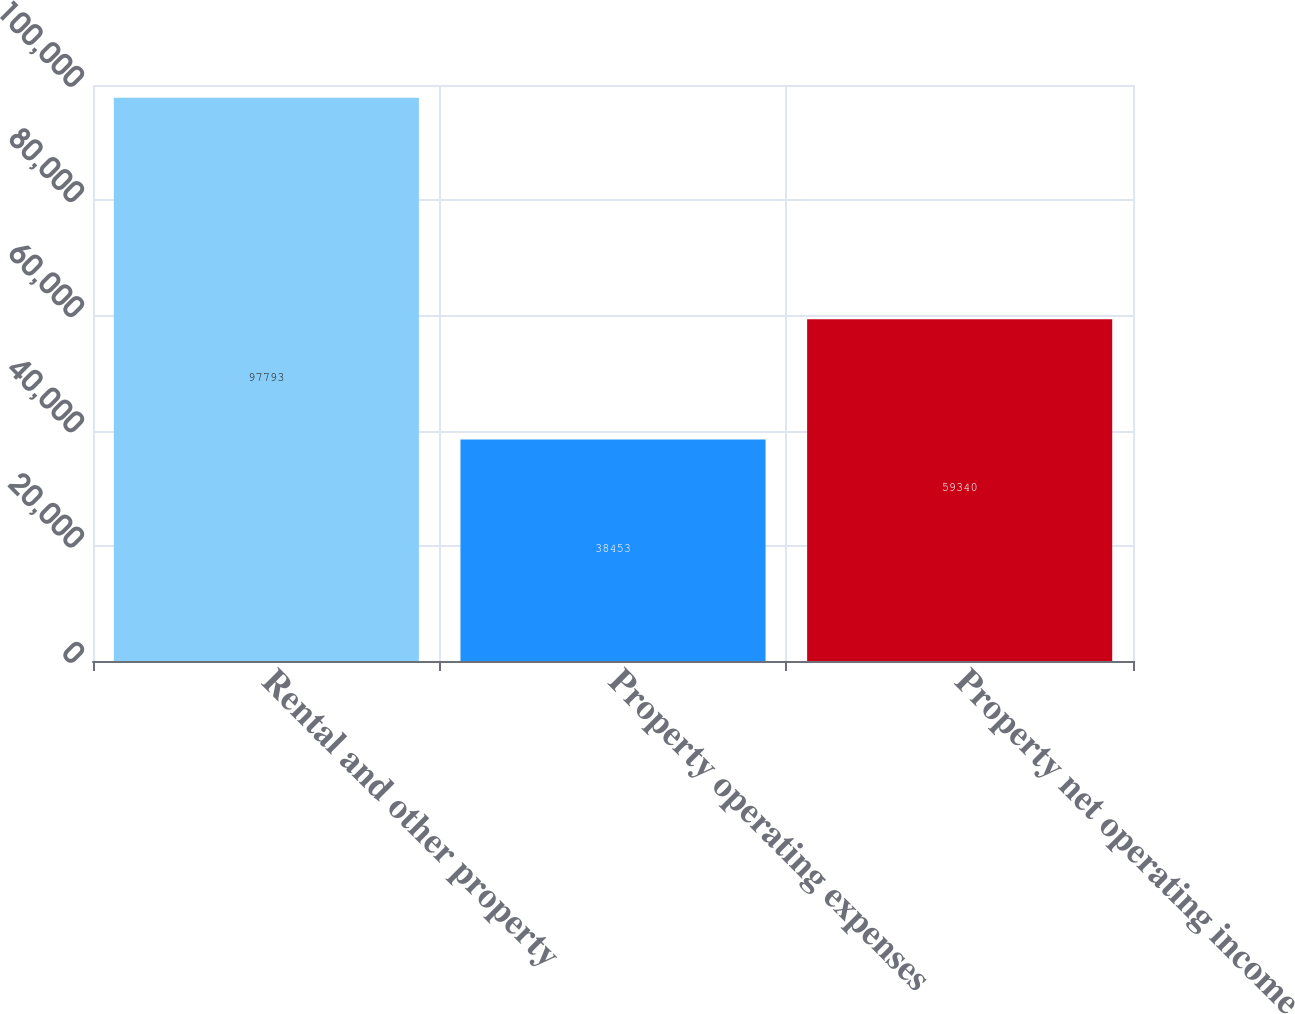Convert chart. <chart><loc_0><loc_0><loc_500><loc_500><bar_chart><fcel>Rental and other property<fcel>Property operating expenses<fcel>Property net operating income<nl><fcel>97793<fcel>38453<fcel>59340<nl></chart> 